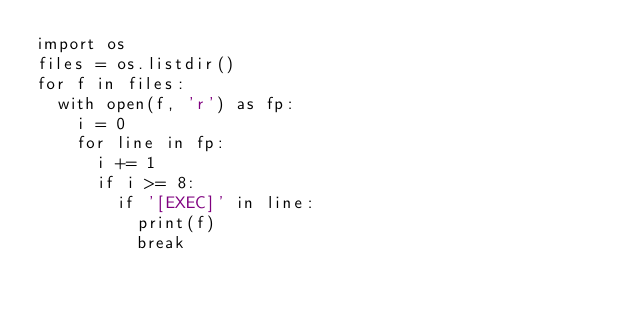<code> <loc_0><loc_0><loc_500><loc_500><_Python_>import os
files = os.listdir()
for f in files:
  with open(f, 'r') as fp:
    i = 0
    for line in fp:
      i += 1
      if i >= 8:
        if '[EXEC]' in line:
          print(f)
          break
</code> 